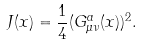Convert formula to latex. <formula><loc_0><loc_0><loc_500><loc_500>J ( x ) = \frac { 1 } { 4 } ( G _ { \mu \nu } ^ { a } ( x ) ) ^ { 2 } .</formula> 